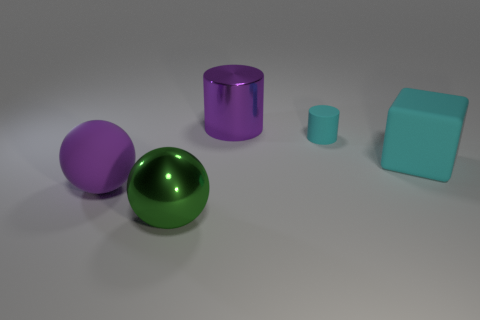How many balls are either large cyan rubber things or matte things?
Make the answer very short. 1. What shape is the object that is in front of the small cyan matte cylinder and behind the purple rubber thing?
Provide a short and direct response. Cube. Is there a ball of the same size as the purple metallic thing?
Ensure brevity in your answer.  Yes. How many things are either large metallic things behind the large cyan matte cube or gray matte blocks?
Offer a very short reply. 1. Is the block made of the same material as the large ball behind the green metallic thing?
Ensure brevity in your answer.  Yes. What number of other objects are the same shape as the large cyan matte object?
Ensure brevity in your answer.  0. How many objects are either big purple objects that are behind the tiny cyan rubber cylinder or big purple things behind the matte ball?
Make the answer very short. 1. What number of other objects are the same color as the tiny rubber cylinder?
Provide a succinct answer. 1. Is the number of metal cylinders on the right side of the small rubber thing less than the number of cyan rubber things that are left of the green ball?
Give a very brief answer. No. How many big cyan matte things are there?
Offer a very short reply. 1. 